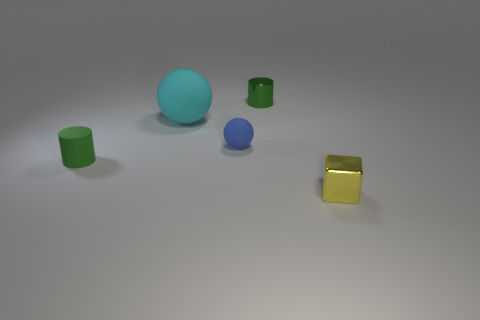Add 4 metal cylinders. How many objects exist? 9 Subtract all spheres. How many objects are left? 3 Subtract all brown metal objects. Subtract all tiny yellow things. How many objects are left? 4 Add 5 small green cylinders. How many small green cylinders are left? 7 Add 5 large cyan rubber things. How many large cyan rubber things exist? 6 Subtract 0 brown balls. How many objects are left? 5 